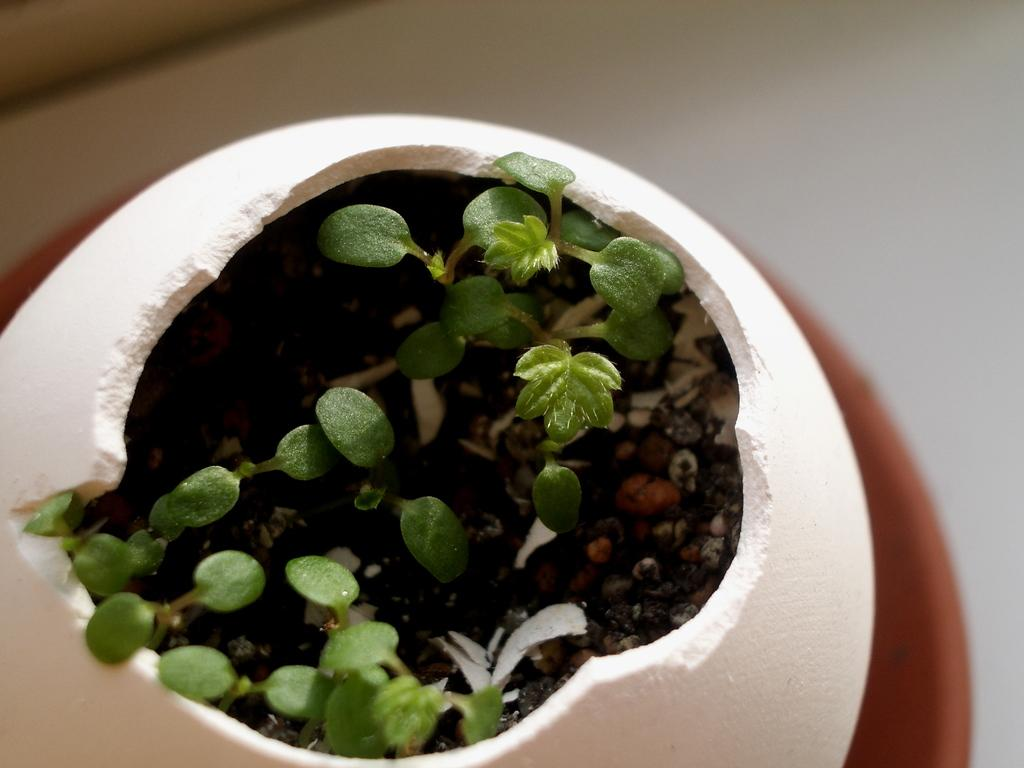What type of objects are present in the image? There are little plants in the image. What can you tell about the pot in which the plants are placed? The plants are in a white color pot. Where is the zipper located on the shelf in the image? There is no shelf or zipper present in the image; it only features little plants in a white color pot. 